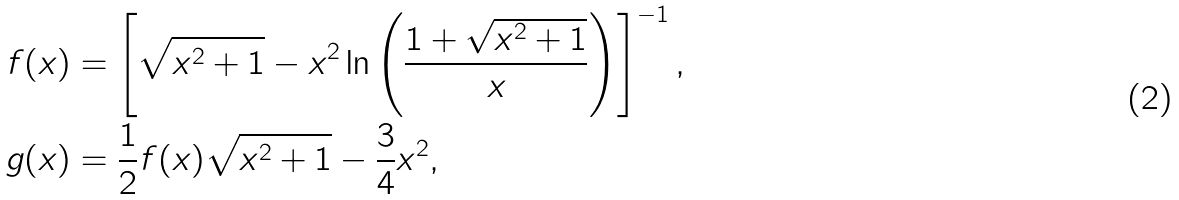<formula> <loc_0><loc_0><loc_500><loc_500>f ( x ) & = \left [ \sqrt { x ^ { 2 } + 1 } - x ^ { 2 } \ln \left ( \frac { 1 + \sqrt { x ^ { 2 } + 1 } } { x } \right ) \right ] ^ { - 1 } , \\ g ( x ) & = \frac { 1 } { 2 } f ( x ) \sqrt { x ^ { 2 } + 1 } - \frac { 3 } { 4 } x ^ { 2 } ,</formula> 